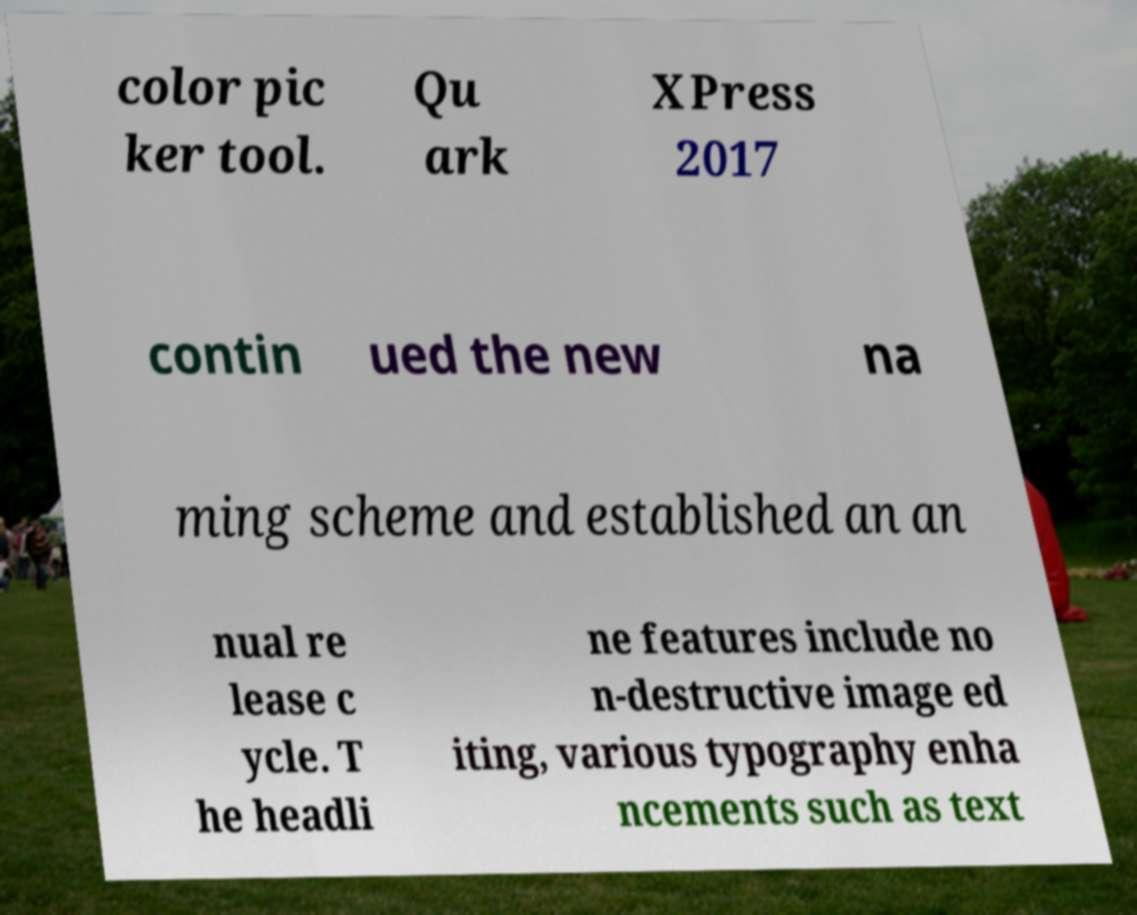What messages or text are displayed in this image? I need them in a readable, typed format. color pic ker tool. Qu ark XPress 2017 contin ued the new na ming scheme and established an an nual re lease c ycle. T he headli ne features include no n-destructive image ed iting, various typography enha ncements such as text 